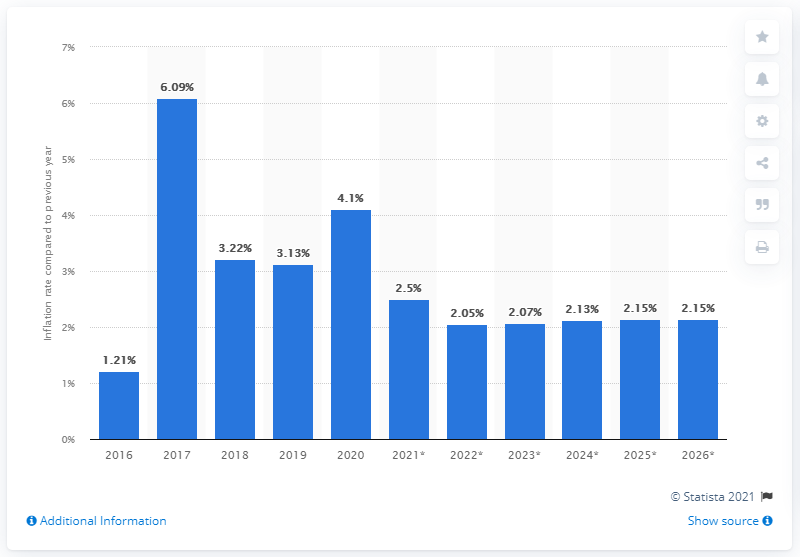Indicate a few pertinent items in this graphic. In 2020, the average inflation rate in Somalia reached 4.1 percent. The inflation rate in Somalia was 4.1% in 2020. 